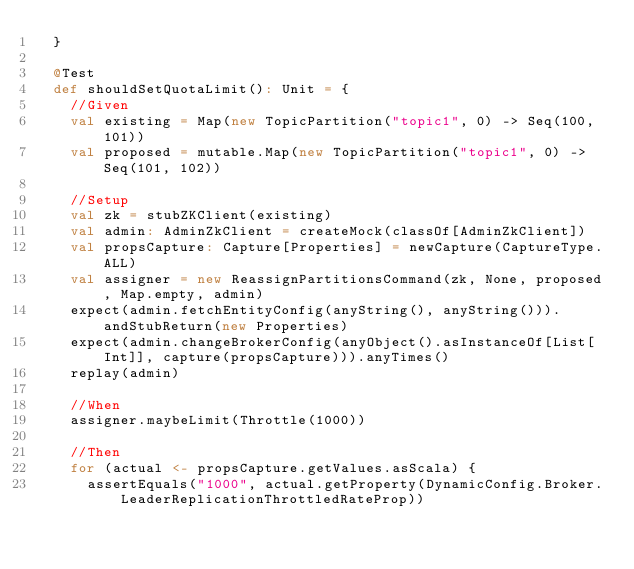<code> <loc_0><loc_0><loc_500><loc_500><_Scala_>  }

  @Test
  def shouldSetQuotaLimit(): Unit = {
    //Given
    val existing = Map(new TopicPartition("topic1", 0) -> Seq(100, 101))
    val proposed = mutable.Map(new TopicPartition("topic1", 0) -> Seq(101, 102))

    //Setup
    val zk = stubZKClient(existing)
    val admin: AdminZkClient = createMock(classOf[AdminZkClient])
    val propsCapture: Capture[Properties] = newCapture(CaptureType.ALL)
    val assigner = new ReassignPartitionsCommand(zk, None, proposed, Map.empty, admin)
    expect(admin.fetchEntityConfig(anyString(), anyString())).andStubReturn(new Properties)
    expect(admin.changeBrokerConfig(anyObject().asInstanceOf[List[Int]], capture(propsCapture))).anyTimes()
    replay(admin)

    //When
    assigner.maybeLimit(Throttle(1000))

    //Then
    for (actual <- propsCapture.getValues.asScala) {
      assertEquals("1000", actual.getProperty(DynamicConfig.Broker.LeaderReplicationThrottledRateProp))</code> 